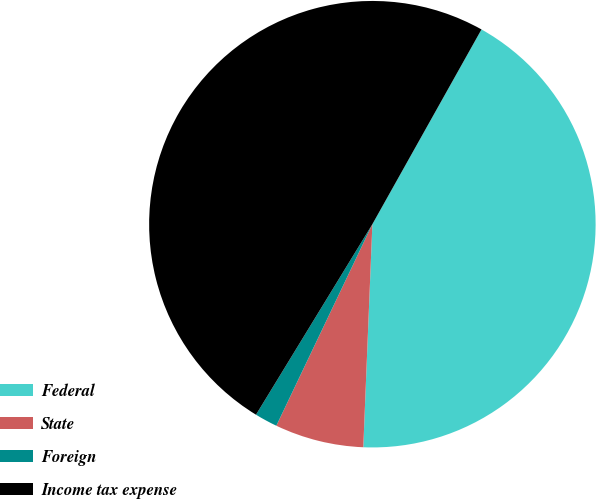<chart> <loc_0><loc_0><loc_500><loc_500><pie_chart><fcel>Federal<fcel>State<fcel>Foreign<fcel>Income tax expense<nl><fcel>42.52%<fcel>6.43%<fcel>1.65%<fcel>49.4%<nl></chart> 